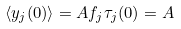Convert formula to latex. <formula><loc_0><loc_0><loc_500><loc_500>\langle y _ { j } ( 0 ) \rangle = A f _ { j } \tau _ { j } ( 0 ) = A</formula> 